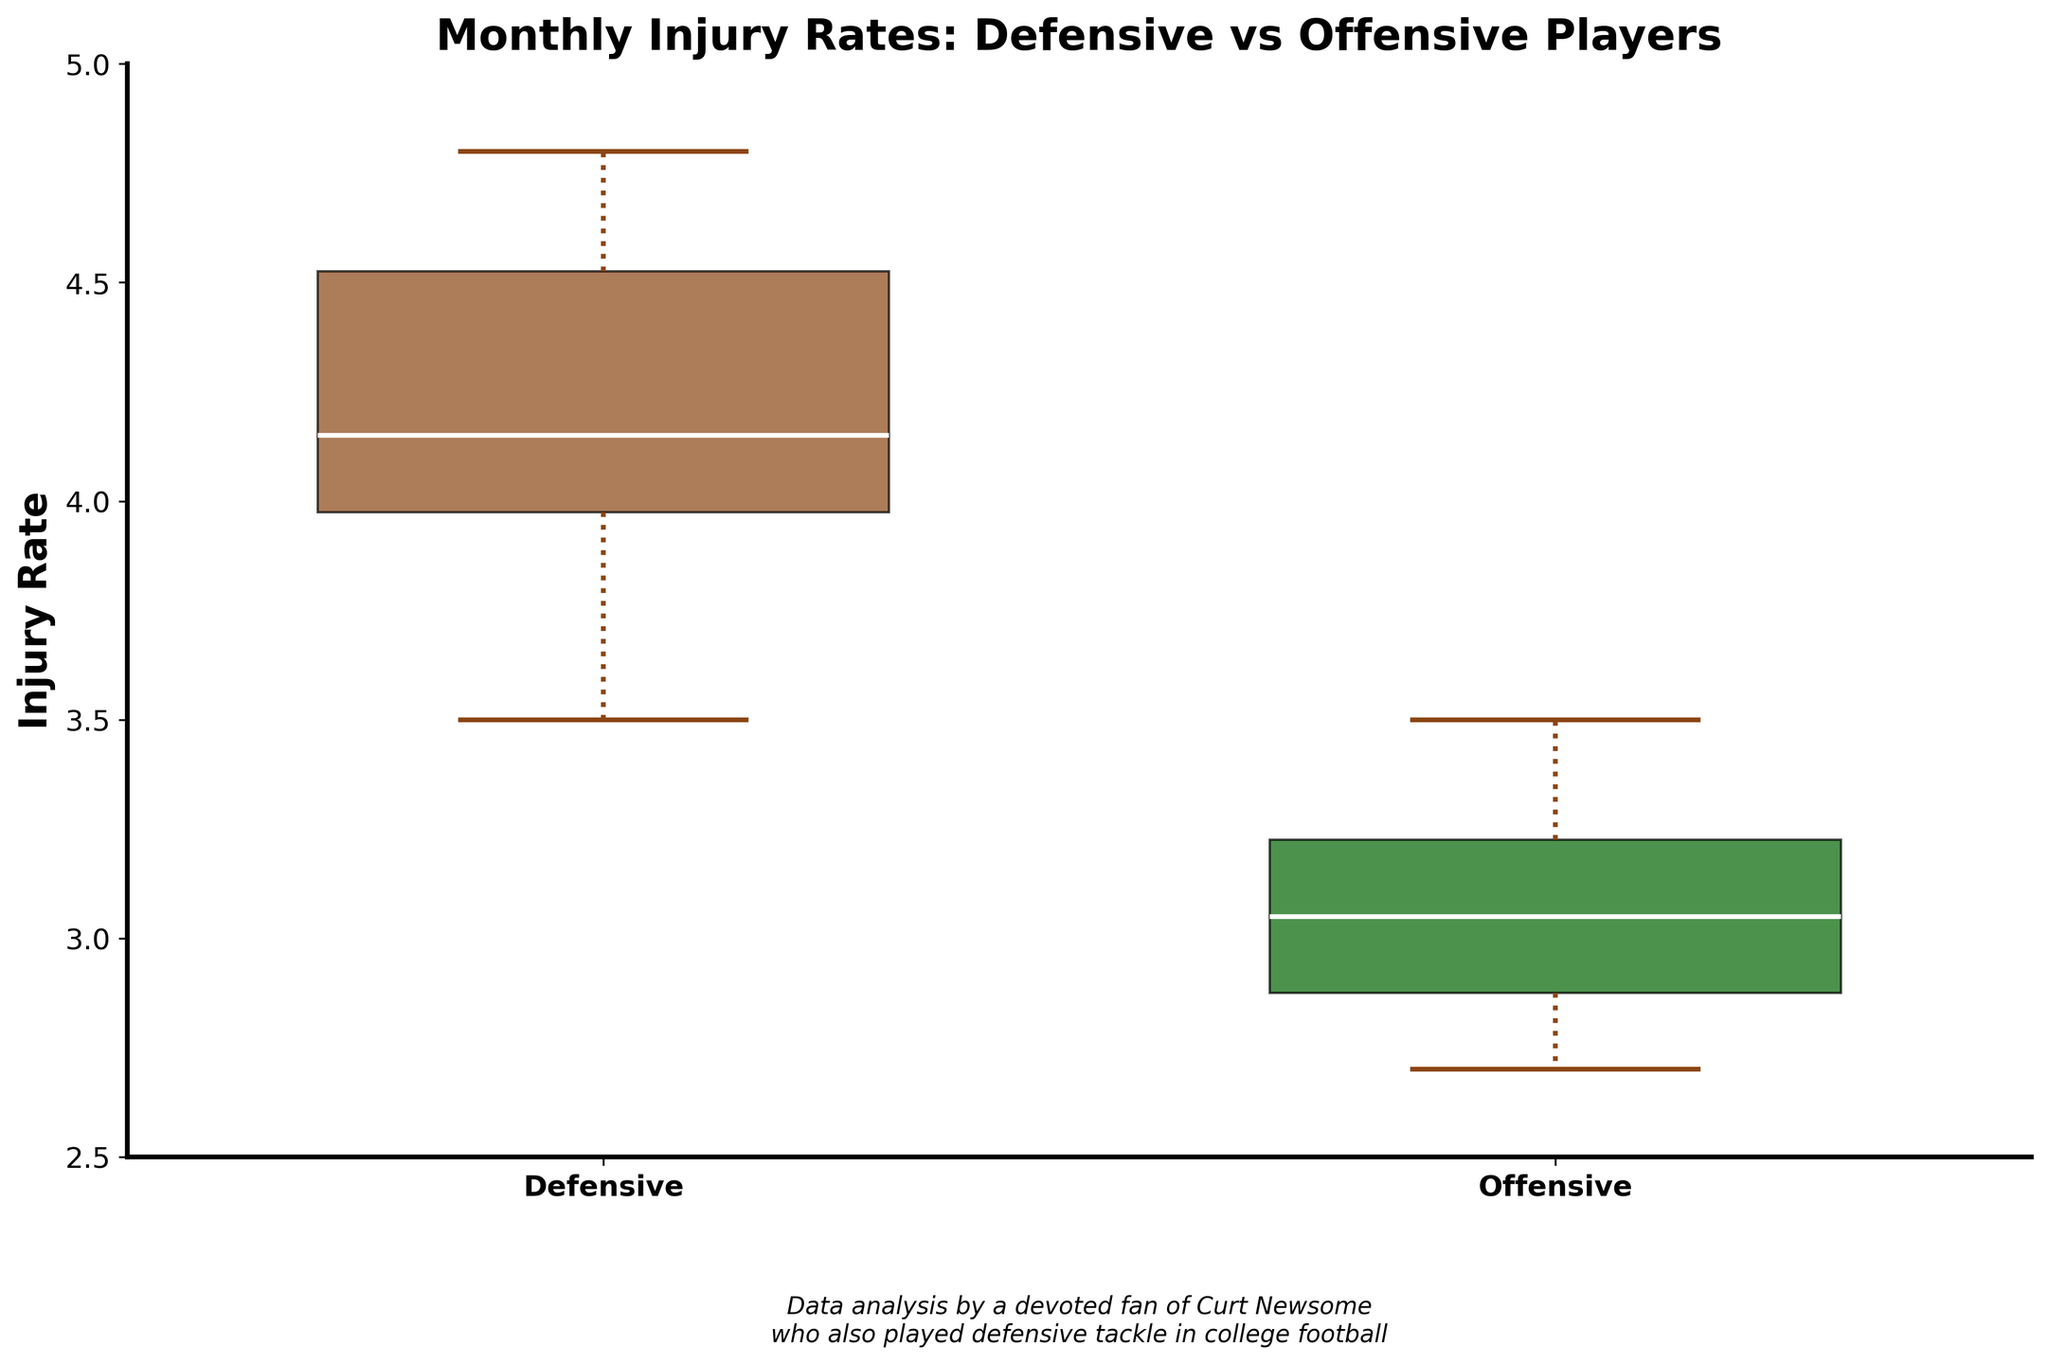What's the title of the box plot? The title of the box plot is displayed at the top of the figure. It reads: "Monthly Injury Rates: Defensive vs Offensive Players."
Answer: Monthly Injury Rates: Defensive vs Offensive Players What does the y-axis represent? The y-axis is labeled on the left side of the plot. It represents the 'Injury Rate' which indicates the rate of injuries per month.
Answer: Injury Rate Which color represents the Defensive players' injury rates? In the box plot, the Defensive players' data is depicted in the box that is colored brownish. This color is used consistently in the plot to represent the Defensive data points.
Answer: Brownish Which group shows a higher median injury rate, Defensive or Offensive players? By observing the median line within the boxes of each group, the box representing the Defensive players has its median line higher than the box representing the Offensive players.
Answer: Defensive players What is the range of the y-axis in the box plot? The y-axis range can be determined by looking at the numeric values presented along the axis. It spans from 2.5 to 5.0.
Answer: 2.5 to 5.0 How do the medians of the two groups compare? The median is marked by a white line within each box. The median for Defensive players is higher than that for Offensive players, indicating that the central injury rate is higher for Defensive players.
Answer: Higher for Defensive players Are there any outliers represented in the box plot? Outliers are typically represented by distinct markers outside the whisker lines. By examining the plot, we can see small circle markers indicating outliers for each group.
Answer: Yes Which group has a wider interquartile range (IQR)? The IQR is indicated by the height of the colored box (difference between the 25th and 75th percentiles). The box for the Defensive players is taller compared to the box for Offensive players, indicating a wider IQR.
Answer: Defensive players What can you infer about the consistency of injury rates between Defensive and Offensive players? Consistency can be assessed by examining the spread and range of the data points. Defensive players show a wider IQR and higher overall range, indicating less consistency and greater variability in injury rates compared to Offensive players.
Answer: Defensive players have less consistency 